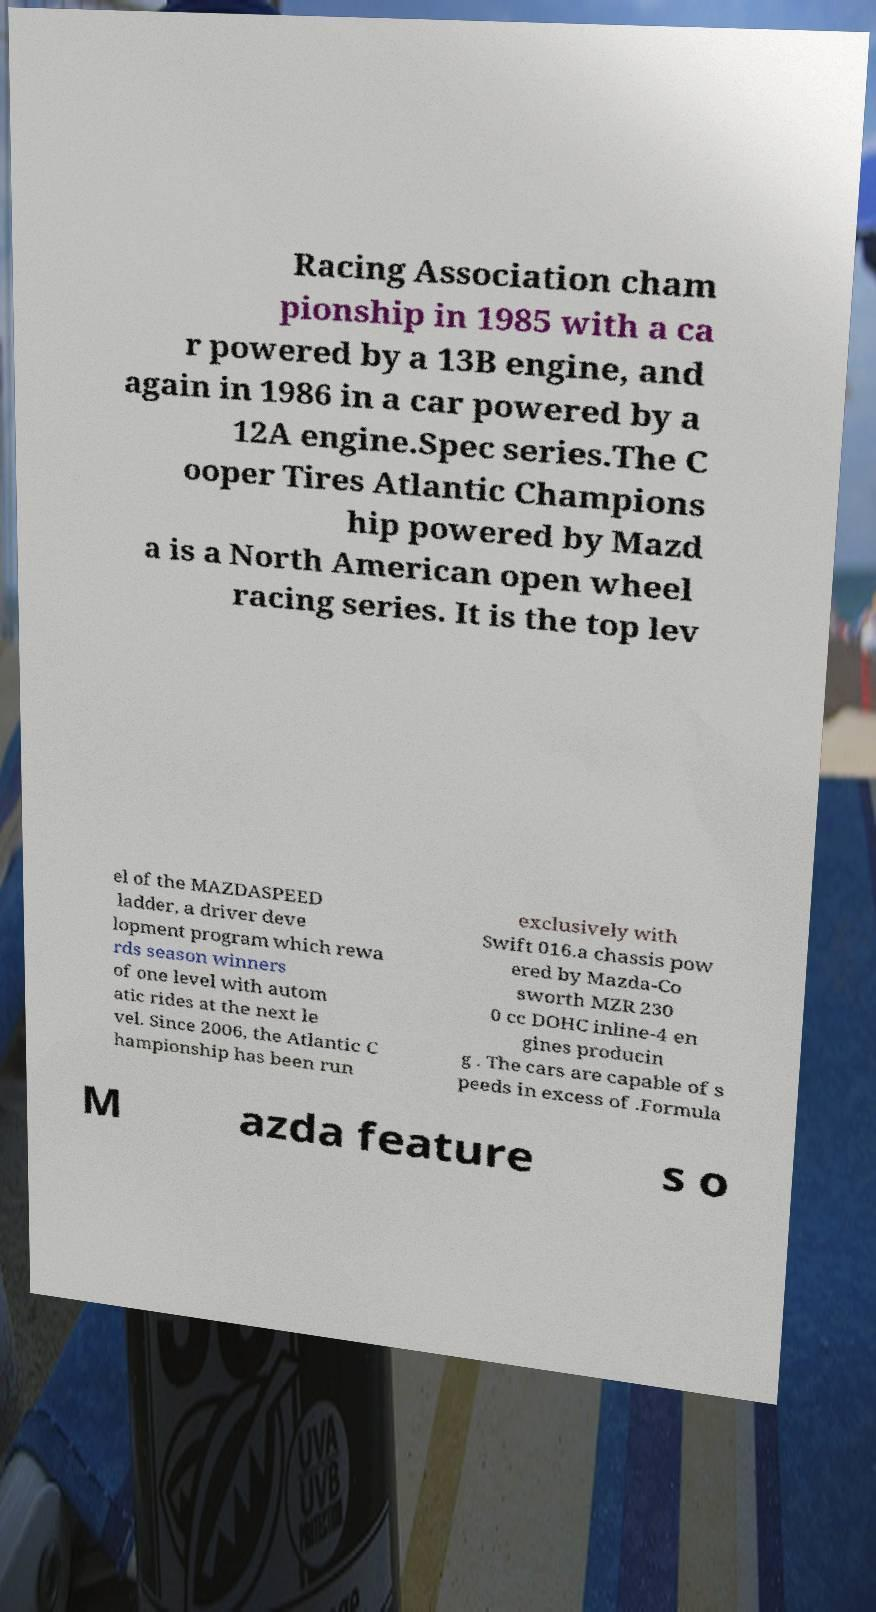Could you assist in decoding the text presented in this image and type it out clearly? Racing Association cham pionship in 1985 with a ca r powered by a 13B engine, and again in 1986 in a car powered by a 12A engine.Spec series.The C ooper Tires Atlantic Champions hip powered by Mazd a is a North American open wheel racing series. It is the top lev el of the MAZDASPEED ladder, a driver deve lopment program which rewa rds season winners of one level with autom atic rides at the next le vel. Since 2006, the Atlantic C hampionship has been run exclusively with Swift 016.a chassis pow ered by Mazda-Co sworth MZR 230 0 cc DOHC inline-4 en gines producin g . The cars are capable of s peeds in excess of .Formula M azda feature s o 